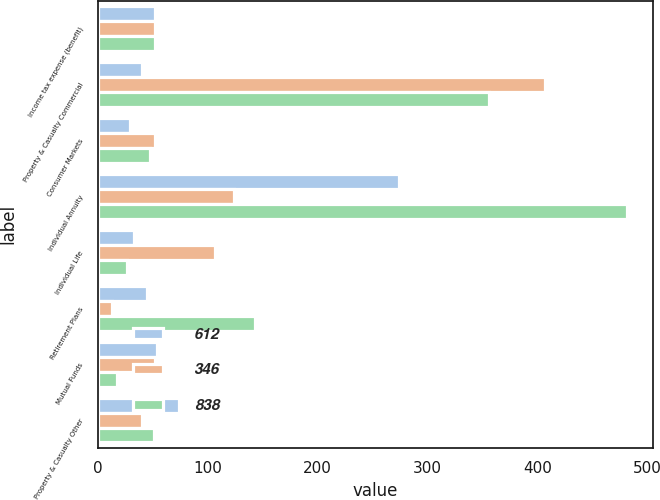Convert chart. <chart><loc_0><loc_0><loc_500><loc_500><stacked_bar_chart><ecel><fcel>Income tax expense (benefit)<fcel>Property & Casualty Commercial<fcel>Consumer Markets<fcel>Individual Annuity<fcel>Individual Life<fcel>Retirement Plans<fcel>Mutual Funds<fcel>Property & Casualty Other<nl><fcel>612<fcel>52<fcel>40<fcel>29<fcel>274<fcel>33<fcel>45<fcel>54<fcel>74<nl><fcel>346<fcel>52<fcel>407<fcel>52<fcel>124<fcel>107<fcel>13<fcel>52<fcel>40<nl><fcel>838<fcel>52<fcel>356<fcel>48<fcel>481<fcel>27<fcel>143<fcel>18<fcel>51<nl></chart> 